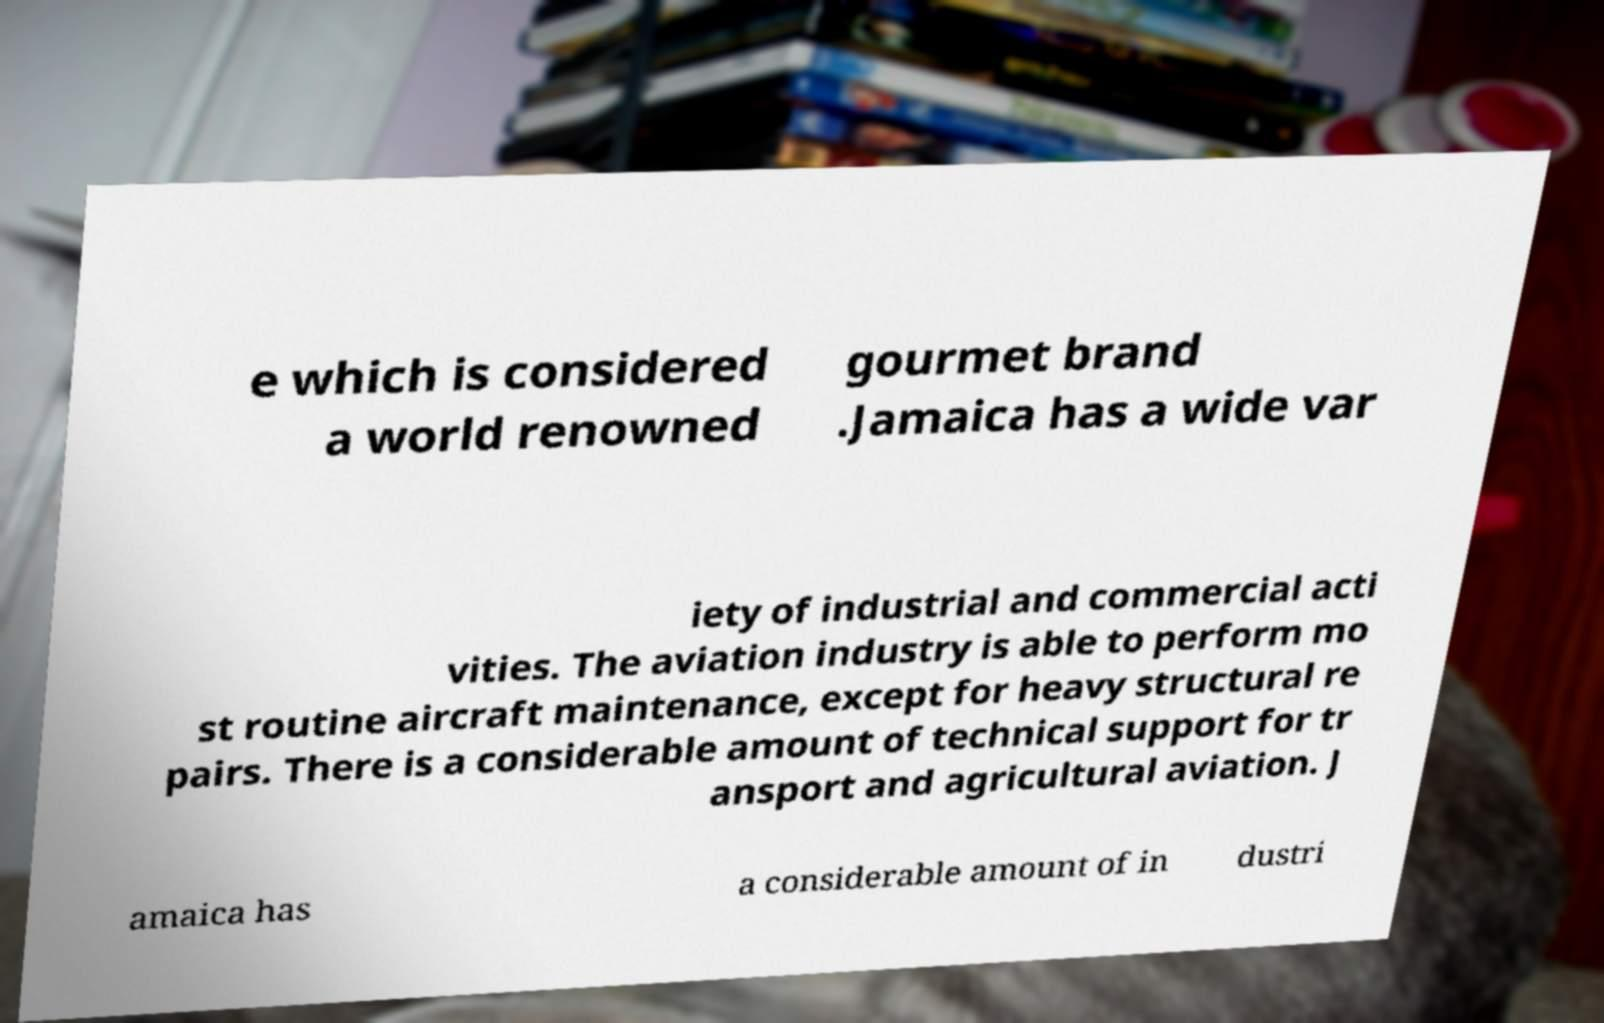Could you extract and type out the text from this image? e which is considered a world renowned gourmet brand .Jamaica has a wide var iety of industrial and commercial acti vities. The aviation industry is able to perform mo st routine aircraft maintenance, except for heavy structural re pairs. There is a considerable amount of technical support for tr ansport and agricultural aviation. J amaica has a considerable amount of in dustri 